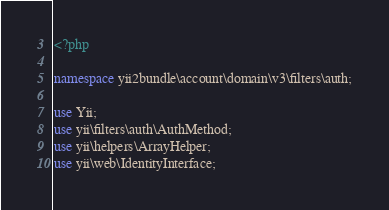<code> <loc_0><loc_0><loc_500><loc_500><_PHP_><?php

namespace yii2bundle\account\domain\v3\filters\auth;

use Yii;
use yii\filters\auth\AuthMethod;
use yii\helpers\ArrayHelper;
use yii\web\IdentityInterface;</code> 